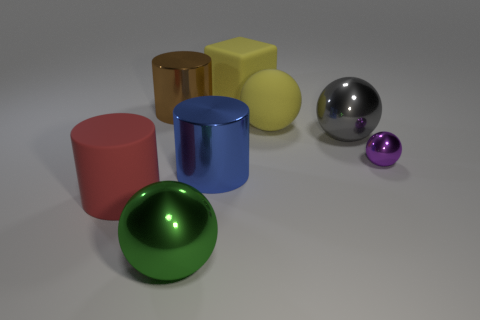Is there any other thing that has the same size as the purple object?
Make the answer very short. No. How many things are either balls to the right of the brown shiny thing or cylinders behind the tiny purple object?
Your answer should be very brief. 5. Is there any other thing that is the same color as the rubber ball?
Your answer should be compact. Yes. What is the color of the metallic cylinder that is in front of the large metal cylinder that is behind the big sphere behind the big gray sphere?
Offer a very short reply. Blue. What size is the thing that is to the right of the big shiny sphere behind the green shiny ball?
Give a very brief answer. Small. The large ball that is both on the left side of the gray metal thing and on the right side of the big green ball is made of what material?
Make the answer very short. Rubber. Is the size of the green shiny object the same as the metal sphere right of the gray ball?
Provide a succinct answer. No. Are any large brown rubber cylinders visible?
Ensure brevity in your answer.  No. There is a big yellow object that is the same shape as the small metallic thing; what is it made of?
Your answer should be compact. Rubber. What size is the purple metallic sphere in front of the object behind the metallic cylinder on the left side of the green thing?
Provide a succinct answer. Small. 